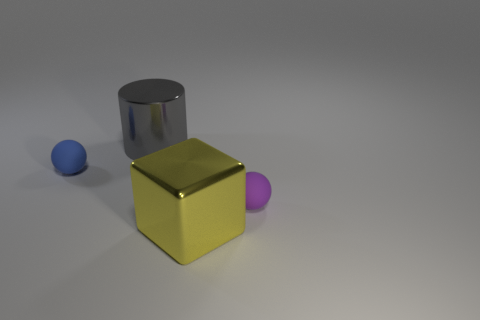Considering the lighting and shadows, at what time of day do you think this photo might resemble? Since the image is likely a computer-generated rendering, we can't pinpoint an exact time of day as we would in a natural environment. However, if we consider the soft shadowing and diffuse light present, it could mimic an overcast day, where objects are lit without harsh shadows, likely midday when natural ambient light is evenly distributed. 